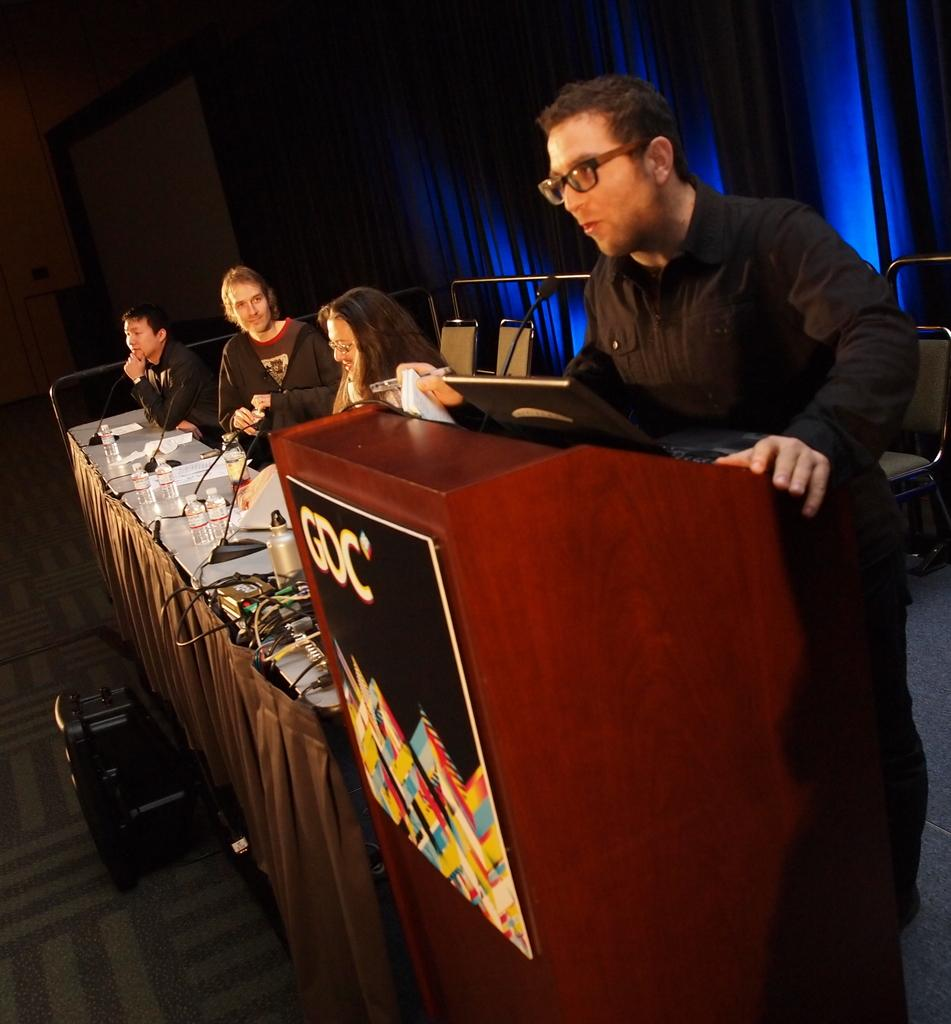What are the people in the image doing? The people in the image are seated on chairs. What is the man at the front of the image doing? The man is standing at a podium and speaking with the help of a microphone. What items can be seen on the table in the image? There are water bottles and papers on the table in the image. How far away is the guide from the people in the image? There is no guide mentioned in the image; the man at the podium is speaking with the help of a microphone. What type of crib is visible in the image? There is no crib present in the image. 